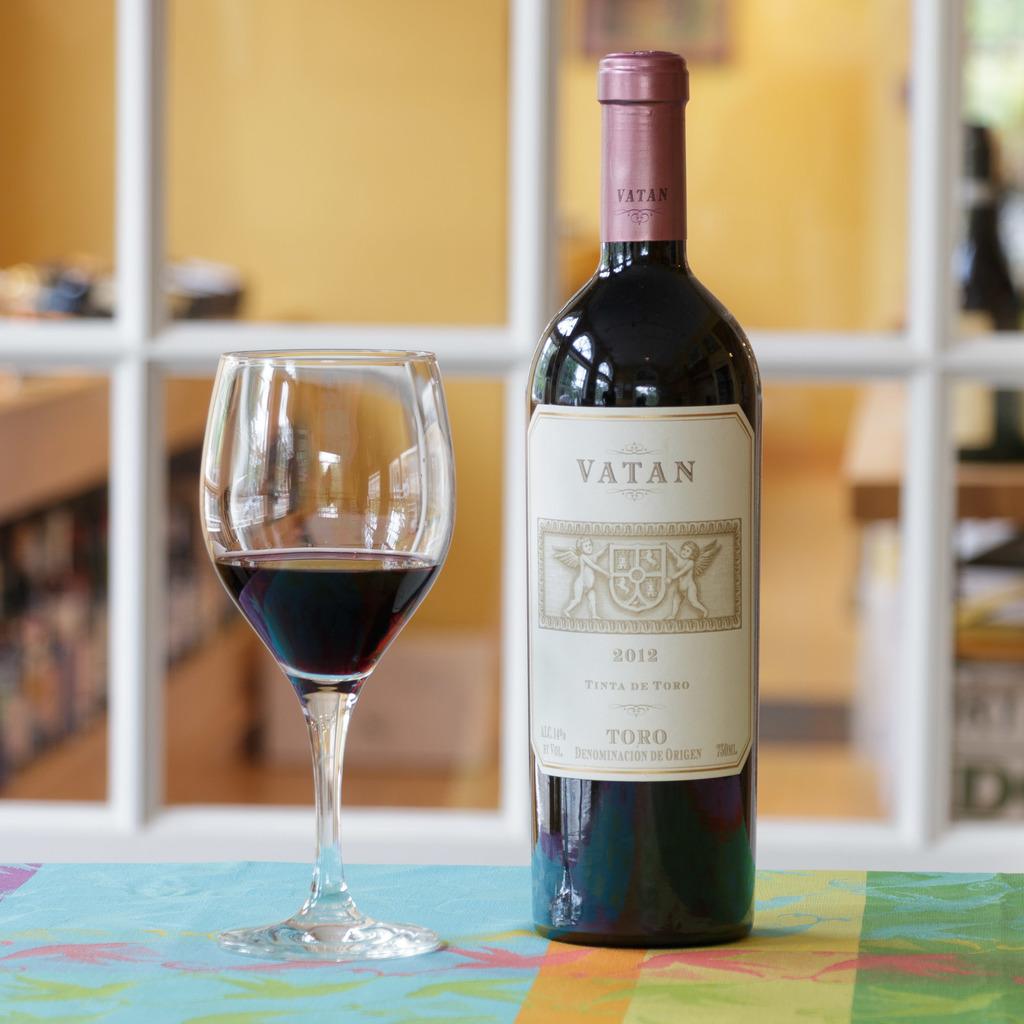From which region is the wine from?
Your answer should be compact. Toro. 